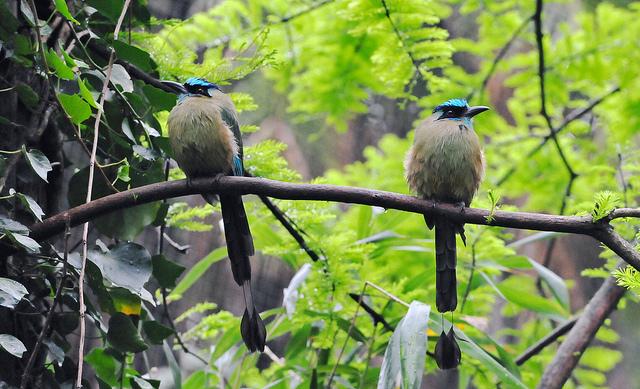How many eyes do you see?
Be succinct. 2. How many birds are in the photo?
Answer briefly. 2. Are the birds outside or inside?
Answer briefly. Outside. Are the birds green?
Keep it brief. No. Are the birds of the same species?
Write a very short answer. Yes. 